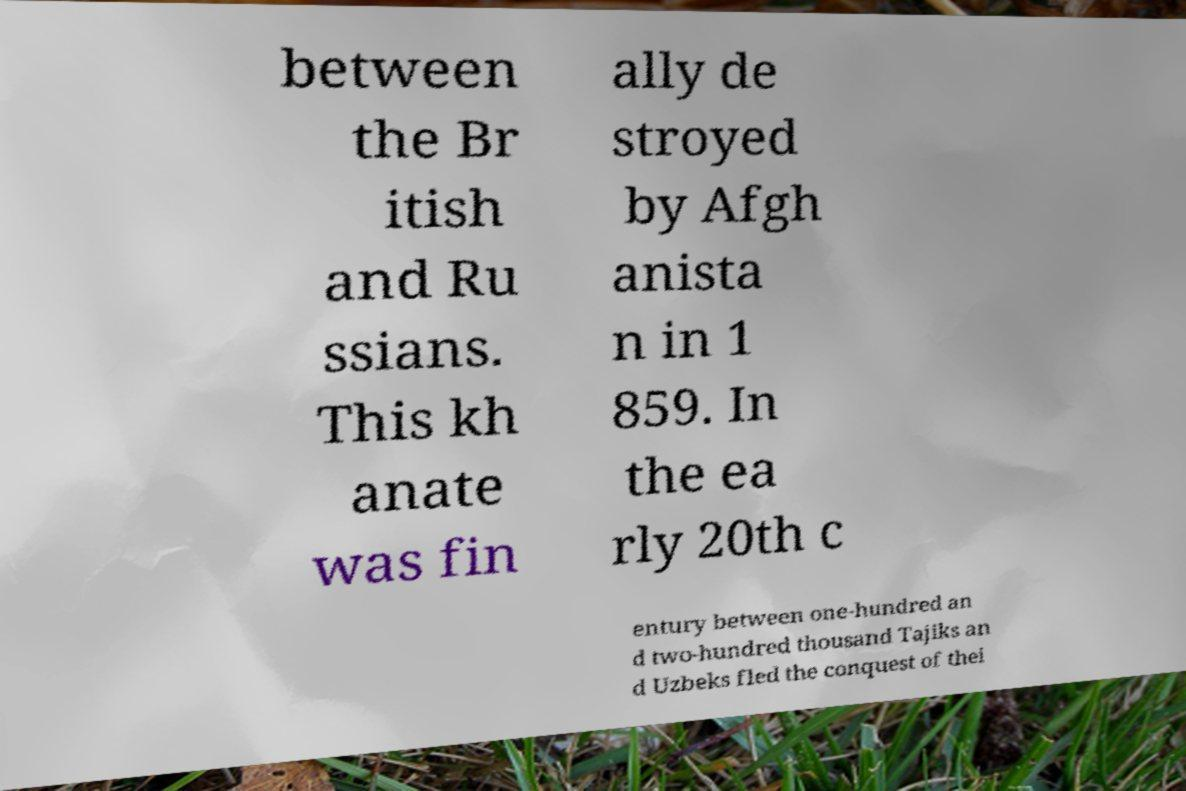What messages or text are displayed in this image? I need them in a readable, typed format. between the Br itish and Ru ssians. This kh anate was fin ally de stroyed by Afgh anista n in 1 859. In the ea rly 20th c entury between one-hundred an d two-hundred thousand Tajiks an d Uzbeks fled the conquest of thei 